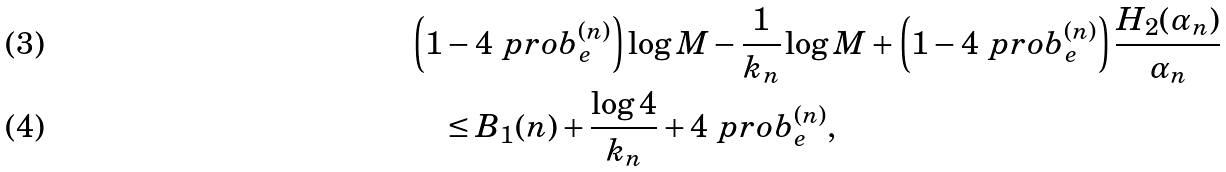Convert formula to latex. <formula><loc_0><loc_0><loc_500><loc_500>& \left ( 1 - 4 \ p r o b _ { e } ^ { ( n ) } \right ) \log M - \frac { 1 } { k _ { n } } \log M + \left ( 1 - 4 \ p r o b _ { e } ^ { ( n ) } \right ) \frac { H _ { 2 } ( \alpha _ { n } ) } { \alpha _ { n } } \\ & \quad \leq B _ { 1 } ( n ) + \frac { \log 4 } { k _ { n } } + 4 \ p r o b _ { e } ^ { ( n ) } ,</formula> 